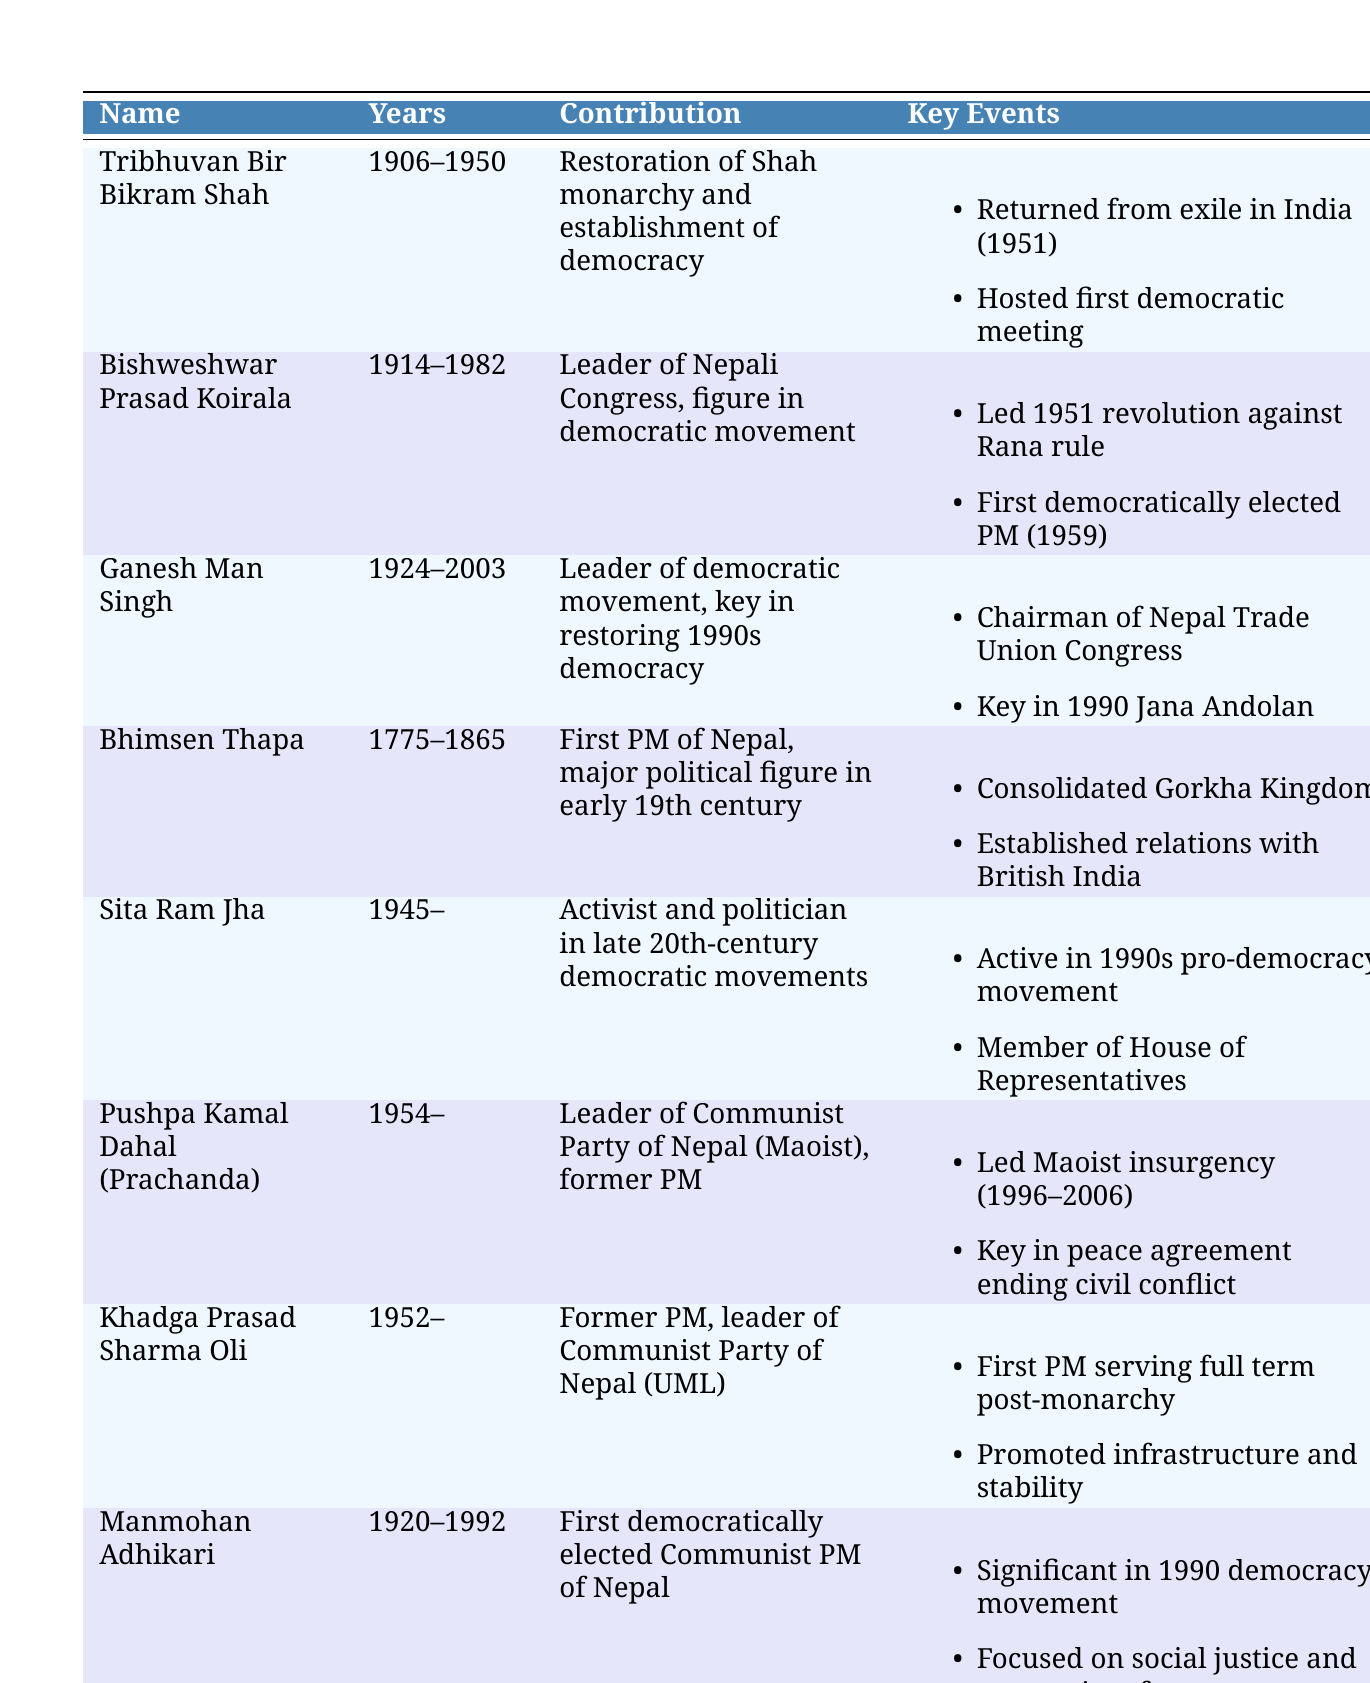What year did Tribhuvan Bir Bikram Shah return from exile? According to the table, Tribhuvan Bir Bikram Shah returned from exile in India in 1951.
Answer: 1951 Who was the first democratically elected Prime Minister of Nepal? The table states that Bishweshwar Prasad Koirala served as the first democratically elected Prime Minister in 1959.
Answer: Bishweshwar Prasad Koirala Which political figure was instrumental in the 1990 people's movement? The entry for Ganesh Man Singh mentions that he was key in the 1990 people's movement, also known as Jana Andolan.
Answer: Ganesh Man Singh Is Sita Ram Jha known for his role in the 1950 revolution against Rana rule? The table does not list Sita Ram Jha as a key figure in the 1950 revolution. His main contributions are highlighted in the pro-democracy movements of the 1990s.
Answer: No How many key events are listed for Pushpa Kamal Dahal (Prachanda)? The table lists two key events for Pushpa Kamal Dahal (Prachanda): leading the Maoist insurgency from 1996 to 2006 and being instrumental in the peace agreement ending the civil conflict.
Answer: 2 What was the contribution of Manmohan Adhikari? The table states that Manmohan Adhikari was the first democratically elected Communist Prime Minister and focused on social justice and economic reform.
Answer: Focused on social justice and economic reform Which two leaders returned Nepal to democracy after the Rana regime? From the table, Tribhuvan Bir Bikram Shah restored the Shah monarchy and established democracy, while Bishweshwar Prasad Koirala was a significant figure in the democratic movement.
Answer: Tribhuvan Bir Bikram Shah and Bishweshwar Prasad Koirala What is the average birth year of the political figures listed in the table? The birth years listed are 1906, 1914, 1924, 1775, 1945, 1954, and 1952. The sum of these years is 1906 + 1914 + 1924 + 1775 + 1945 + 1954 + 1952 = 13,170. There are 7 figures, so the average is 13,170 / 7 = 1,881.42857, rounded to 1881.
Answer: 1881 How many figures have contributions related to restoring democracy in the 1990s? The table shows that both Ganesh Man Singh and Sita Ram Jha contributed to restoring democracy in the 1990s. Thus, a total of 2 figures are related to this contribution.
Answer: 2 